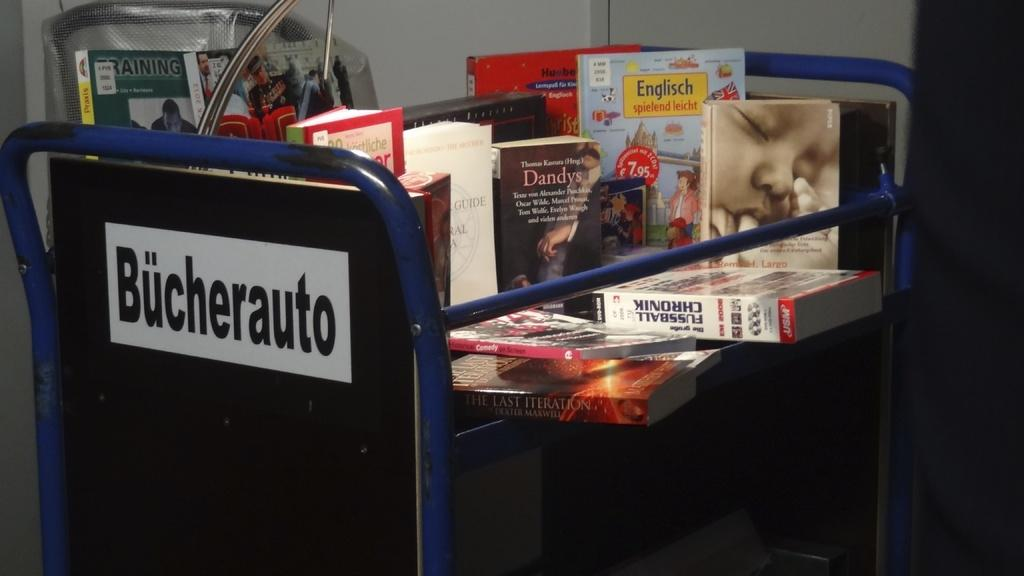<image>
Summarize the visual content of the image. A library cart filled with different titled books with the word Bucherauto on the blue cart 